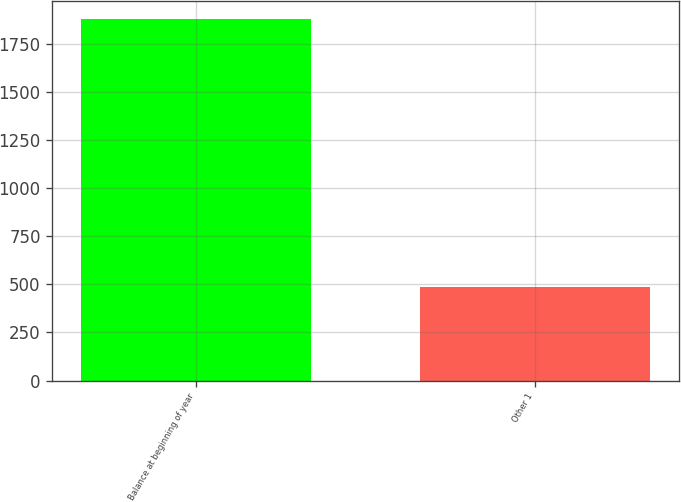Convert chart. <chart><loc_0><loc_0><loc_500><loc_500><bar_chart><fcel>Balance at beginning of year<fcel>Other 1<nl><fcel>1877<fcel>486<nl></chart> 